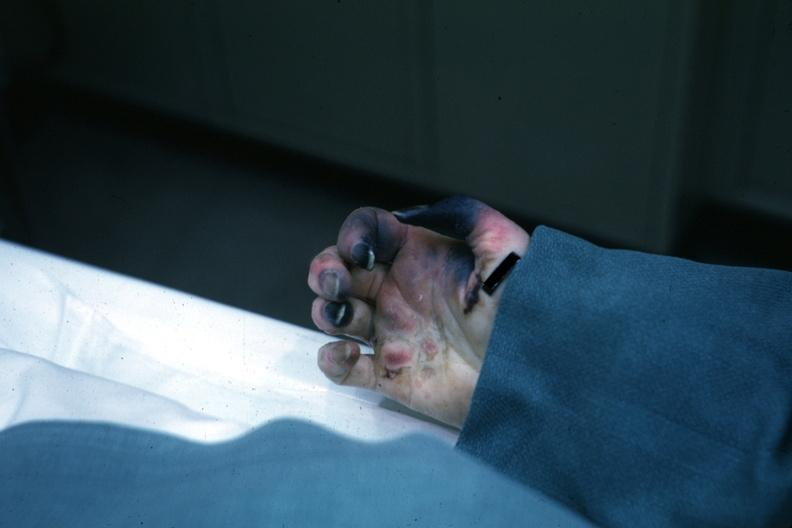s hand present?
Answer the question using a single word or phrase. Yes 